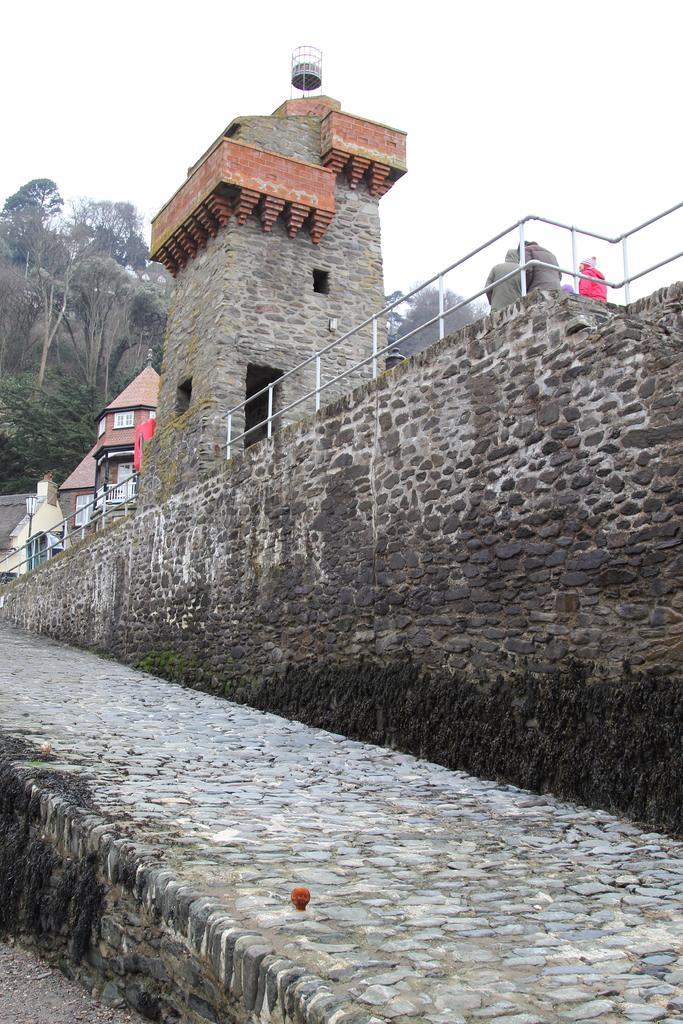Could you give a brief overview of what you see in this image? In the image there are homes on the bridge with some persons standing on the right side in front of the fence, in the front it seems to be a road and in the back there are trees and above its sky. 